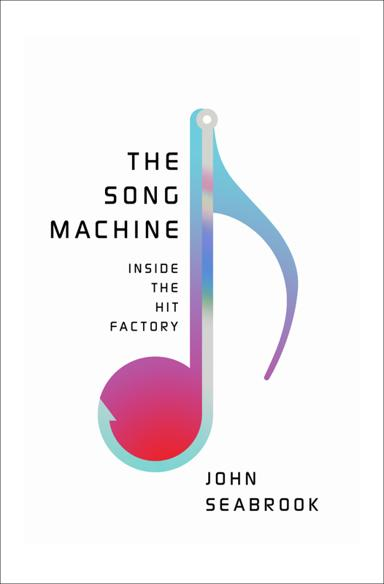Could you explain the symbolism behind the design of the book cover? The cover of 'The Song Machine' features a sleek, modern design that symbolizes the seamless and polished nature of pop music production. The stylized musical note not only represents the book's focus on music but also suggests innovation and the flowing creativity within the music industry. The use of vibrant colors could reflect the energy and diversity of the pop music world. 